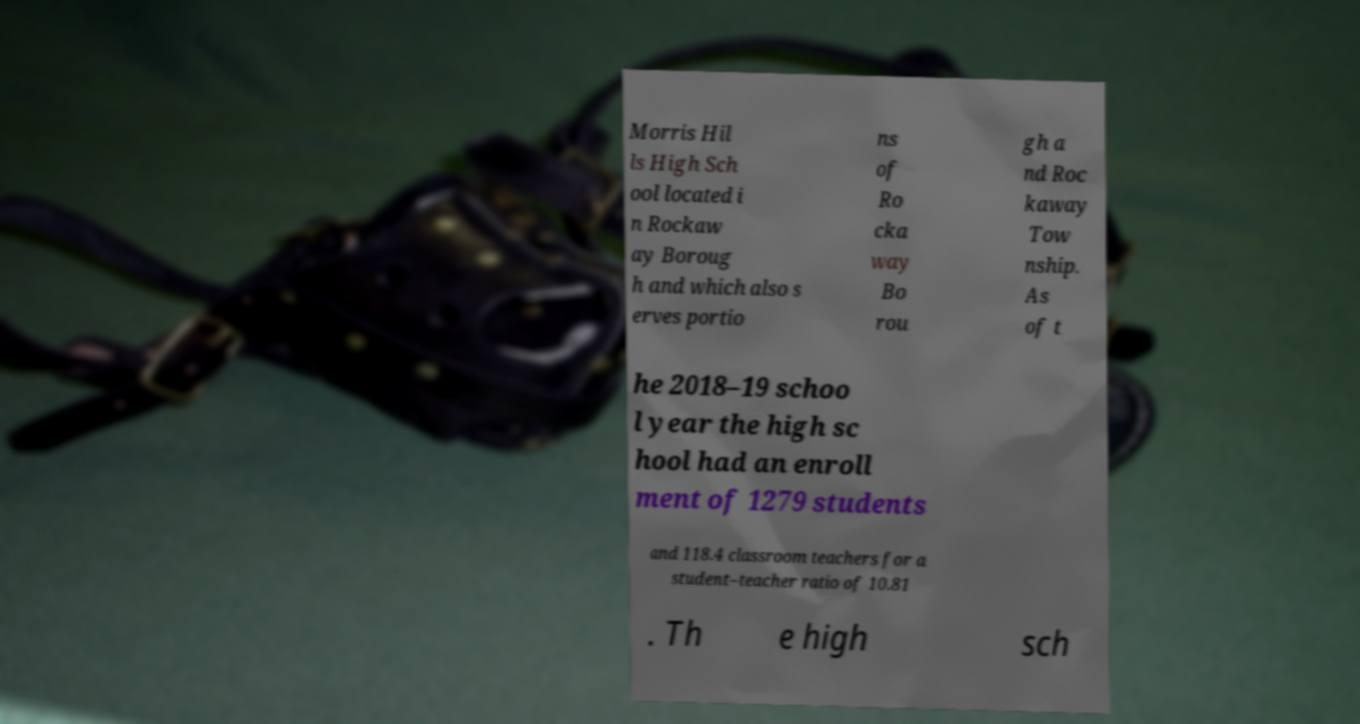For documentation purposes, I need the text within this image transcribed. Could you provide that? Morris Hil ls High Sch ool located i n Rockaw ay Boroug h and which also s erves portio ns of Ro cka way Bo rou gh a nd Roc kaway Tow nship. As of t he 2018–19 schoo l year the high sc hool had an enroll ment of 1279 students and 118.4 classroom teachers for a student–teacher ratio of 10.81 . Th e high sch 